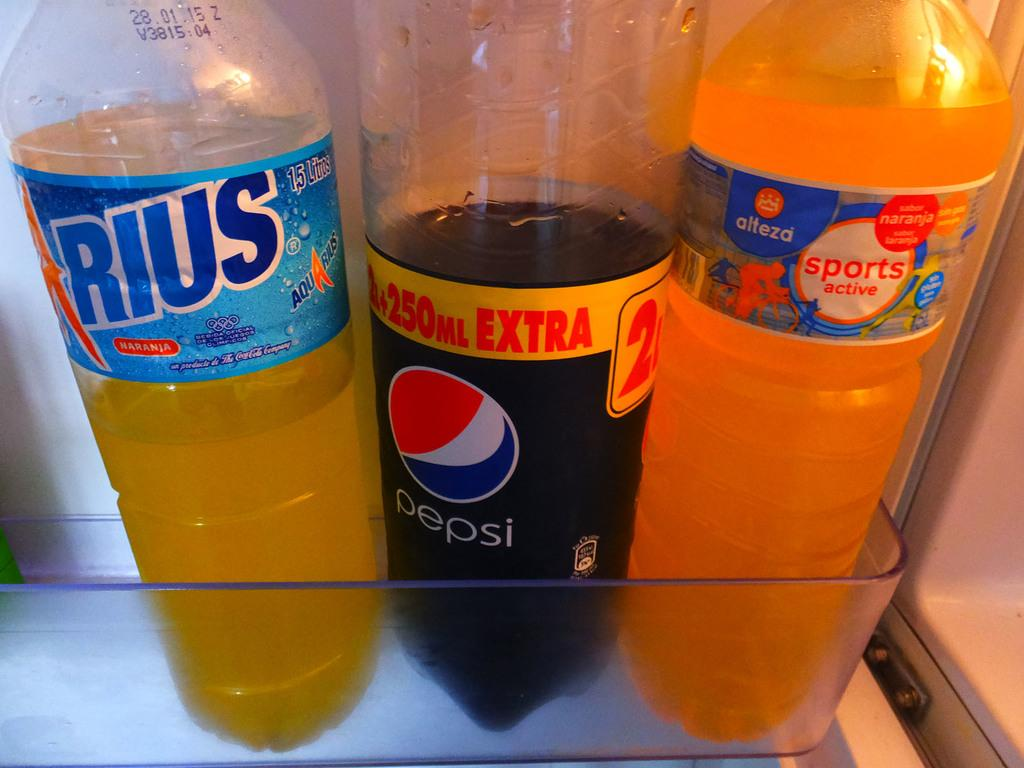<image>
Write a terse but informative summary of the picture. Three bottles of soda on a clear palstic shelf with a Pepsi in the middle 